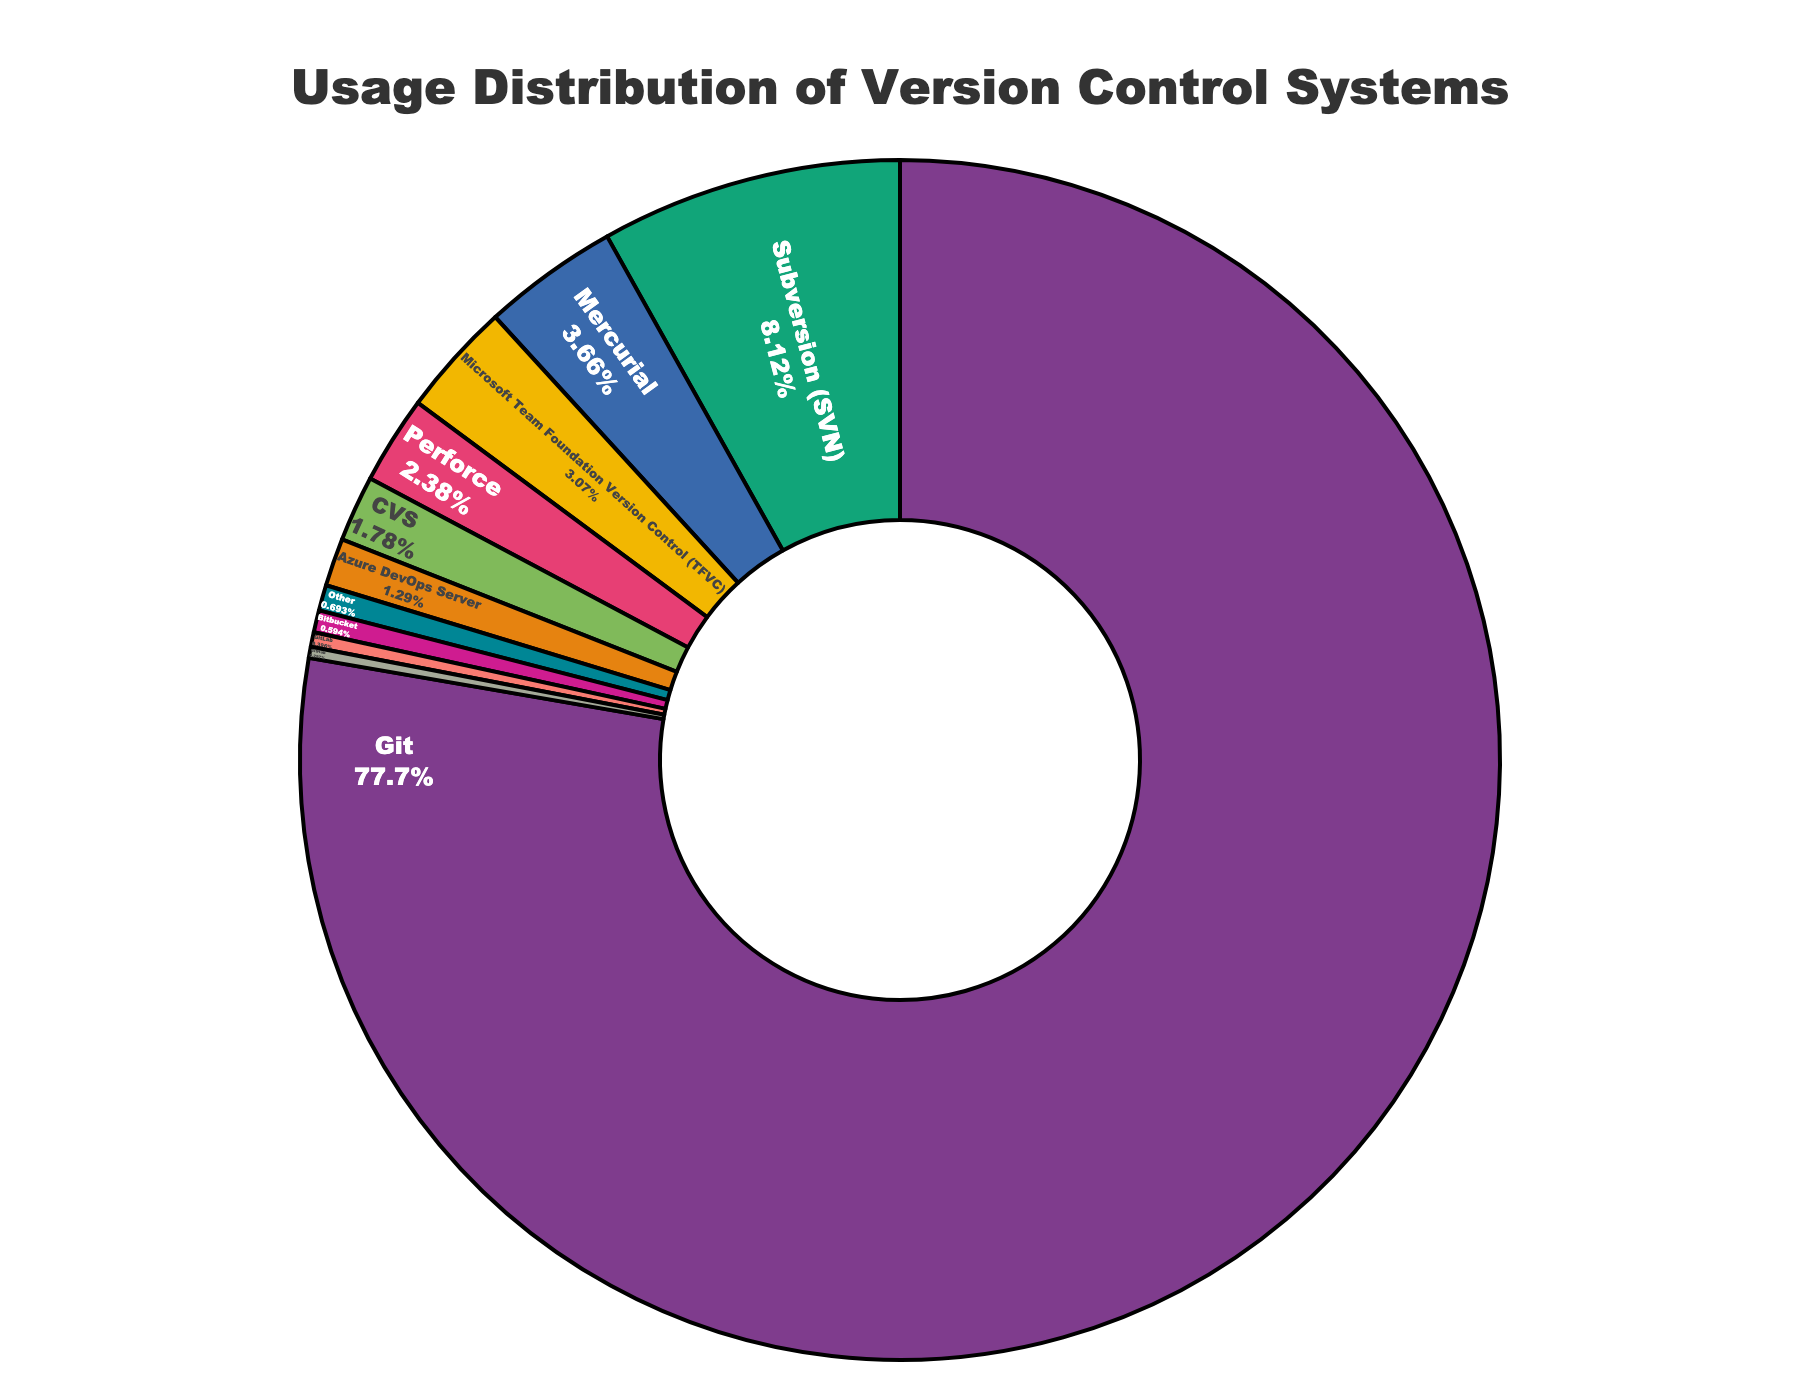what is the most used version control system among developers? The figure shows that Git has the largest percentage of usage among all the listed version control systems.
Answer: Git What is the combined usage percentage of Subversion (SVN) and Mercurial? The usage percentage of Subversion (SVN) is 8.2%, and Mercurial is 3.7%. Adding these together gives 8.2% + 3.7% = 11.9%.
Answer: 11.9% Which version control system has a higher usage, Microsoft Team Foundation Version Control (TFVC) or Perforce? The figure shows that Microsoft Team Foundation Version Control (TFVC) has a usage percentage of 3.1%, while Perforce has 2.4%. Therefore, Microsoft Team Foundation Version Control (TFVC) has a higher usage percentage.
Answer: Microsoft Team Foundation Version Control (TFVC) What is the difference in usage percentage between Git and the second most used version control system? Git has a usage percentage of 78.5%, and the second most used system, Subversion (SVN), has 8.2%. The difference is 78.5% - 8.2% = 70.3%.
Answer: 70.3% What is the cumulative usage percentage of the three least used version control systems? The least used systems are GitLab (0.4%), GitHub (0.3%), and Bitbucket (0.6%). Adding these together gives 0.4% + 0.3% + 0.6% = 1.3%.
Answer: 1.3% Which version control system is represented by the dark blue color in the pie chart? The figure indicates that the colors are assigned based on a custom color palette, with the dark blue section representing Git.
Answer: Git What percentage of developers use version control systems other than Git? The combined usage percentage of all version control systems other than Git is obtained by subtracting Git's usage from 100%. This is 100% - 78.5% = 21.5%.
Answer: 21.5% Compare the usage percentage of Azure DevOps Server and CVS. Which one has a higher usage? According to the figure, Azure DevOps Server has a usage percentage of 1.3%, while CVS has 1.8%. Therefore, CVS has a higher usage percentage.
Answer: CVS How much more popular is Mercurial compared to GitHub? Mercurial has a usage percentage of 3.7%, and GitHub has 0.3%. The difference is 3.7% - 0.3% = 3.4%.
Answer: 3.4% What is the median usage percentage among the listed version control systems? To find the median, list the usage percentages in ascending order: 0.3%, 0.4%, 0.6%, 0.7%, 1.3%, 1.8%, 2.4%, 3.1%, 3.7%, 8.2%, 78.5%. The middle value (6th in the sorted list) is 1.8%.
Answer: 1.8% 